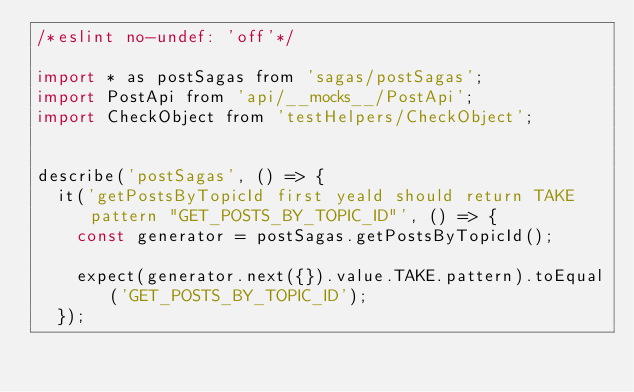Convert code to text. <code><loc_0><loc_0><loc_500><loc_500><_JavaScript_>/*eslint no-undef: 'off'*/

import * as postSagas from 'sagas/postSagas';
import PostApi from 'api/__mocks__/PostApi';
import CheckObject from 'testHelpers/CheckObject';


describe('postSagas', () => {
  it('getPostsByTopicId first yeald should return TAKE pattern "GET_POSTS_BY_TOPIC_ID"', () => {
    const generator = postSagas.getPostsByTopicId();

    expect(generator.next({}).value.TAKE.pattern).toEqual('GET_POSTS_BY_TOPIC_ID');
  });
</code> 